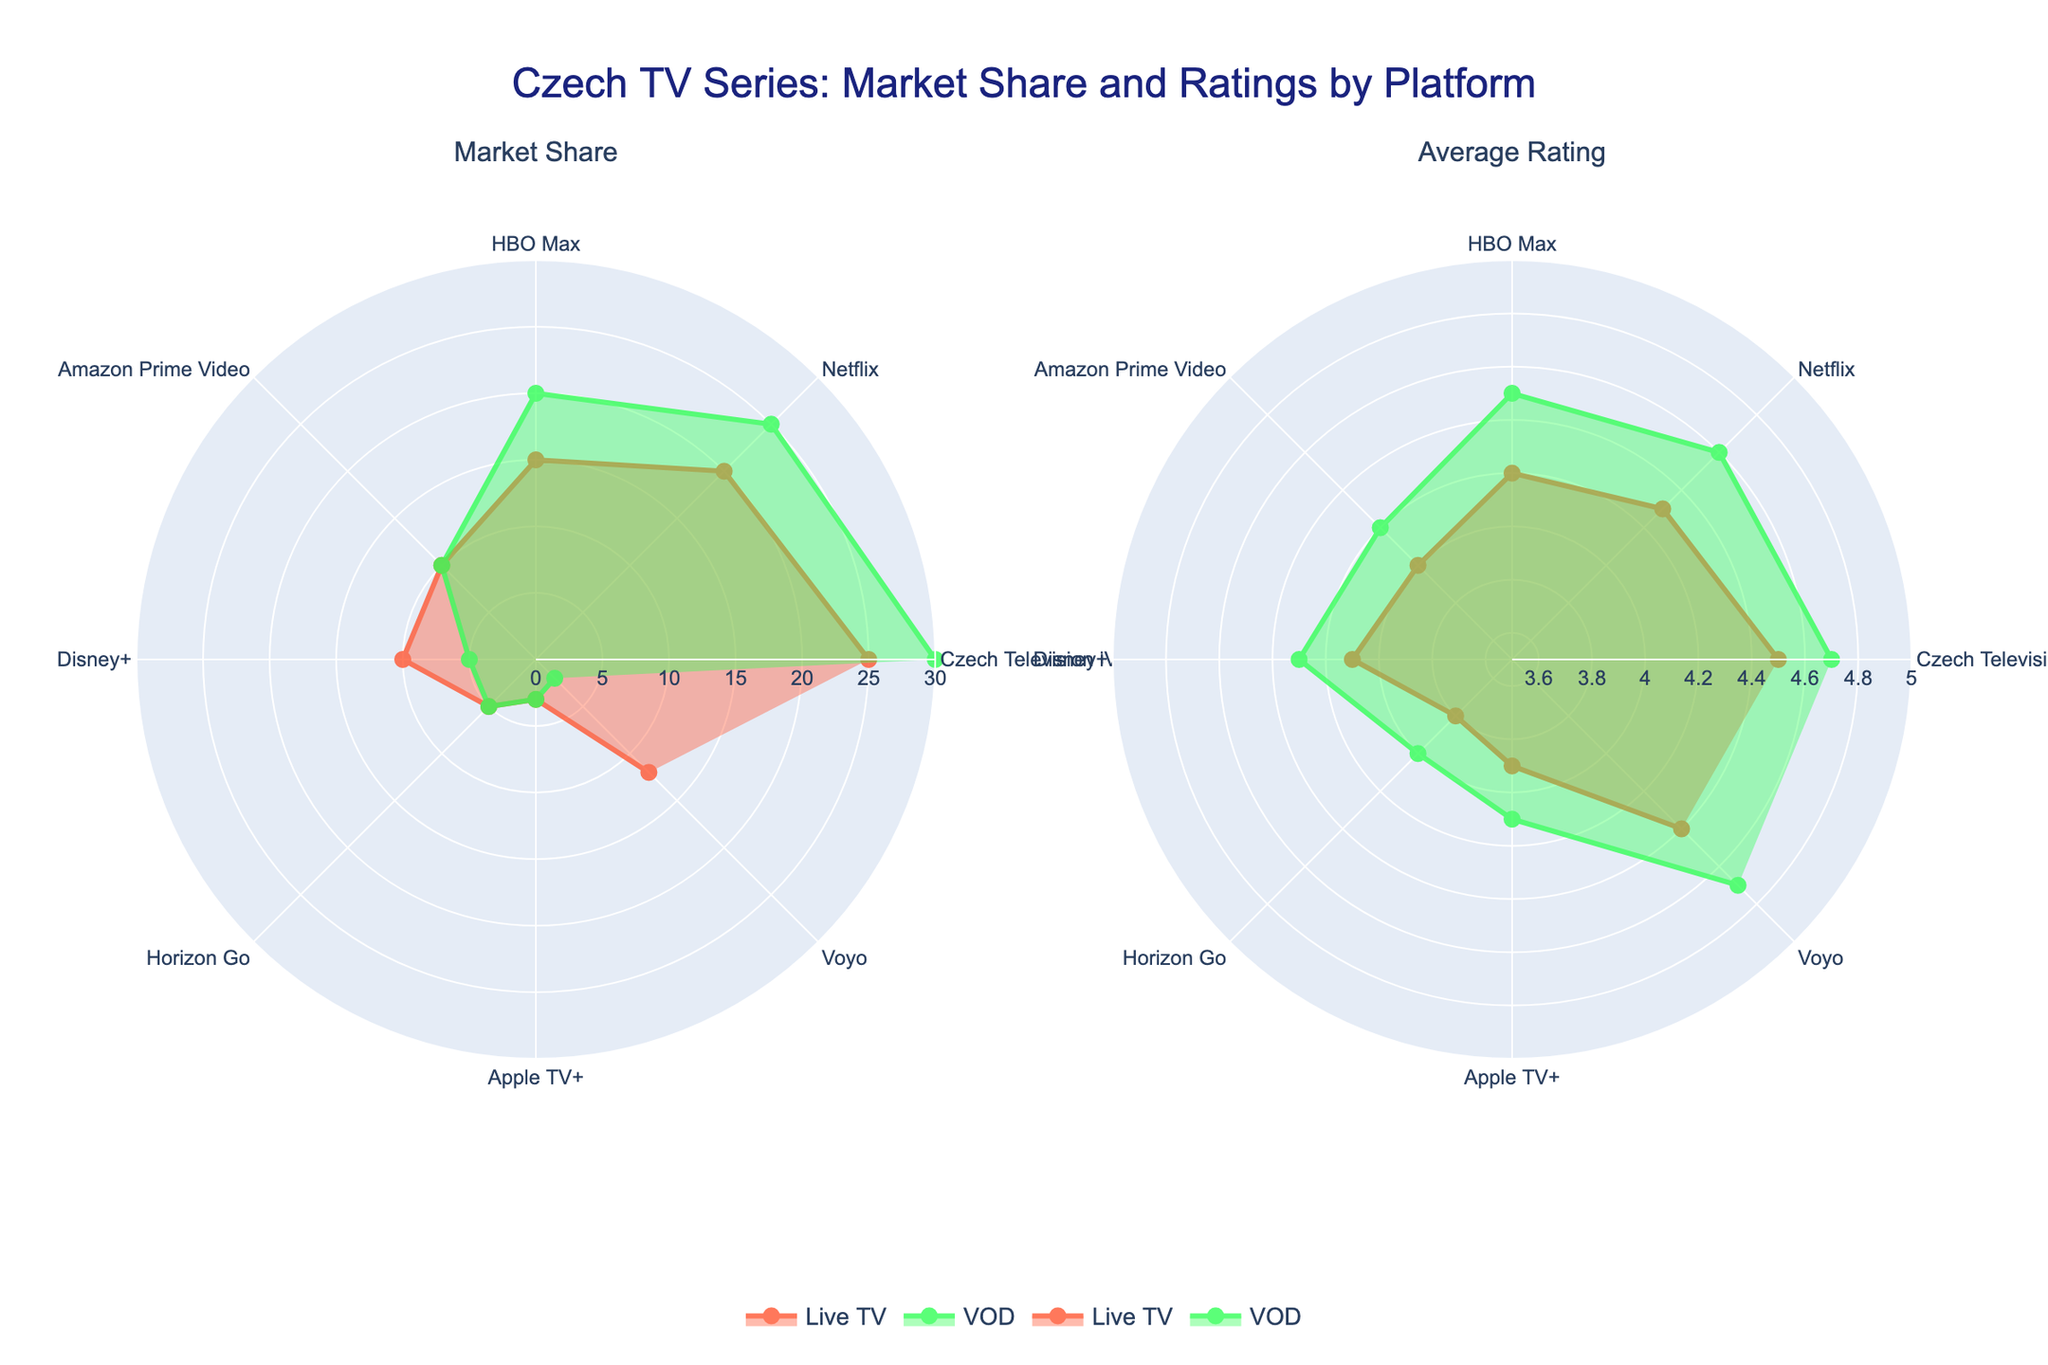What are the platform names shown in the plot? The platform names are displayed as labels around the polar charts. They represent the different TV streaming services included in the analysis.
Answer: Czech Television iVysílání, Netflix, HBO Max, Amazon Prime Video, Disney+, Horizon Go, Apple TV+, Voyo Which platform has the highest market share for Live TV? From the "Market Share" subplot, the largest radius for the "Live TV" trace corresponds to the Czech Television iVysílání platform.
Answer: Czech Television iVysílání How does the market share of Czech Television iVysílání compare between Live TV and VOD? In the "Market Share" subplot, Czech Television iVysílání has a longer radius for VOD compared to Live TV, indicating it has a higher share in VOD.
Answer: Higher in VOD Which two platforms have the smallest market share for both Live TV and VOD? The "Market Share" subplot shows that Horizon Go and Apple TV+ have the smallest radii for both Live TV and VOD.
Answer: Horizon Go, Apple TV+ What is the average rating of Voyo for Live TV? In the "Average Rating" subplot, the radius for the Voyo platform under the Live TV trace corresponds to the rating.
Answer: 4.4 Between Netflix and HBO Max, which platform has a higher average rating for Live TV? In the "Average Rating" subplot, the radius for Netflix under Live TV trace is slightly longer than that for HBO Max.
Answer: Netflix What is the sum of the market share percentages for Amazon Prime Video and Disney+ for Live TV? From the "Market Share" subplot, add the radii corresponding to Amazon Prime Video and Disney+ for Live TV. Amazon Prime Video has 10% and Disney+ has 10%, so the sum is 10% + 10% = 20%.
Answer: 20% How does the average rating for Czech Television iVysílání's VOD compare to its Live TV? In the "Average Rating" subplot, Czech Television iVysílání shows that the radius for VOD is slightly longer than that for Live TV.
Answer: Higher for VOD Which platform has the highest average rating for VOD? From the "Average Rating" subplot, the longest radius in the VOD trace is for Czech Television iVysílání.
Answer: Czech Television iVysílání How does the market share of Netflix for Live TV compare to its VOD? In the "Market Share" subplot, the radii for Netflix are longer for VOD compared to Live TV, indicating a higher market share in VOD.
Answer: Higher in VOD 